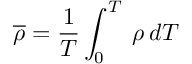<formula> <loc_0><loc_0><loc_500><loc_500>\overline { \rho } = \frac { 1 } { T } \int _ { 0 } ^ { T } \, { \rho } \, d T</formula> 